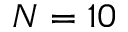Convert formula to latex. <formula><loc_0><loc_0><loc_500><loc_500>N = 1 0</formula> 